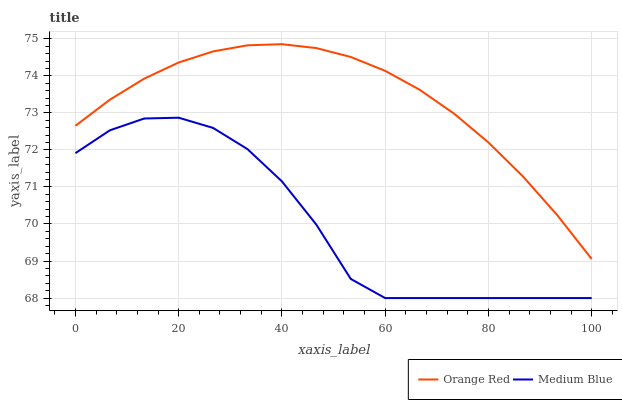Does Medium Blue have the minimum area under the curve?
Answer yes or no. Yes. Does Orange Red have the maximum area under the curve?
Answer yes or no. Yes. Does Orange Red have the minimum area under the curve?
Answer yes or no. No. Is Orange Red the smoothest?
Answer yes or no. Yes. Is Medium Blue the roughest?
Answer yes or no. Yes. Is Orange Red the roughest?
Answer yes or no. No. Does Medium Blue have the lowest value?
Answer yes or no. Yes. Does Orange Red have the lowest value?
Answer yes or no. No. Does Orange Red have the highest value?
Answer yes or no. Yes. Is Medium Blue less than Orange Red?
Answer yes or no. Yes. Is Orange Red greater than Medium Blue?
Answer yes or no. Yes. Does Medium Blue intersect Orange Red?
Answer yes or no. No. 